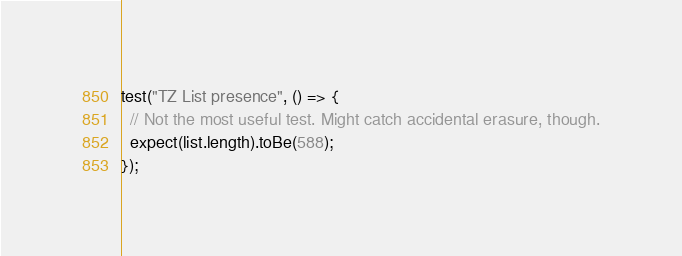Convert code to text. <code><loc_0><loc_0><loc_500><loc_500><_TypeScript_>test("TZ List presence", () => {
  // Not the most useful test. Might catch accidental erasure, though.
  expect(list.length).toBe(588);
});
</code> 